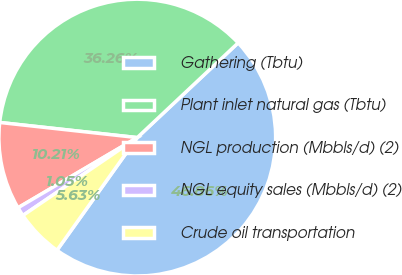<chart> <loc_0><loc_0><loc_500><loc_500><pie_chart><fcel>Gathering (Tbtu)<fcel>Plant inlet natural gas (Tbtu)<fcel>NGL production (Mbbls/d) (2)<fcel>NGL equity sales (Mbbls/d) (2)<fcel>Crude oil transportation<nl><fcel>46.86%<fcel>36.26%<fcel>10.21%<fcel>1.05%<fcel>5.63%<nl></chart> 